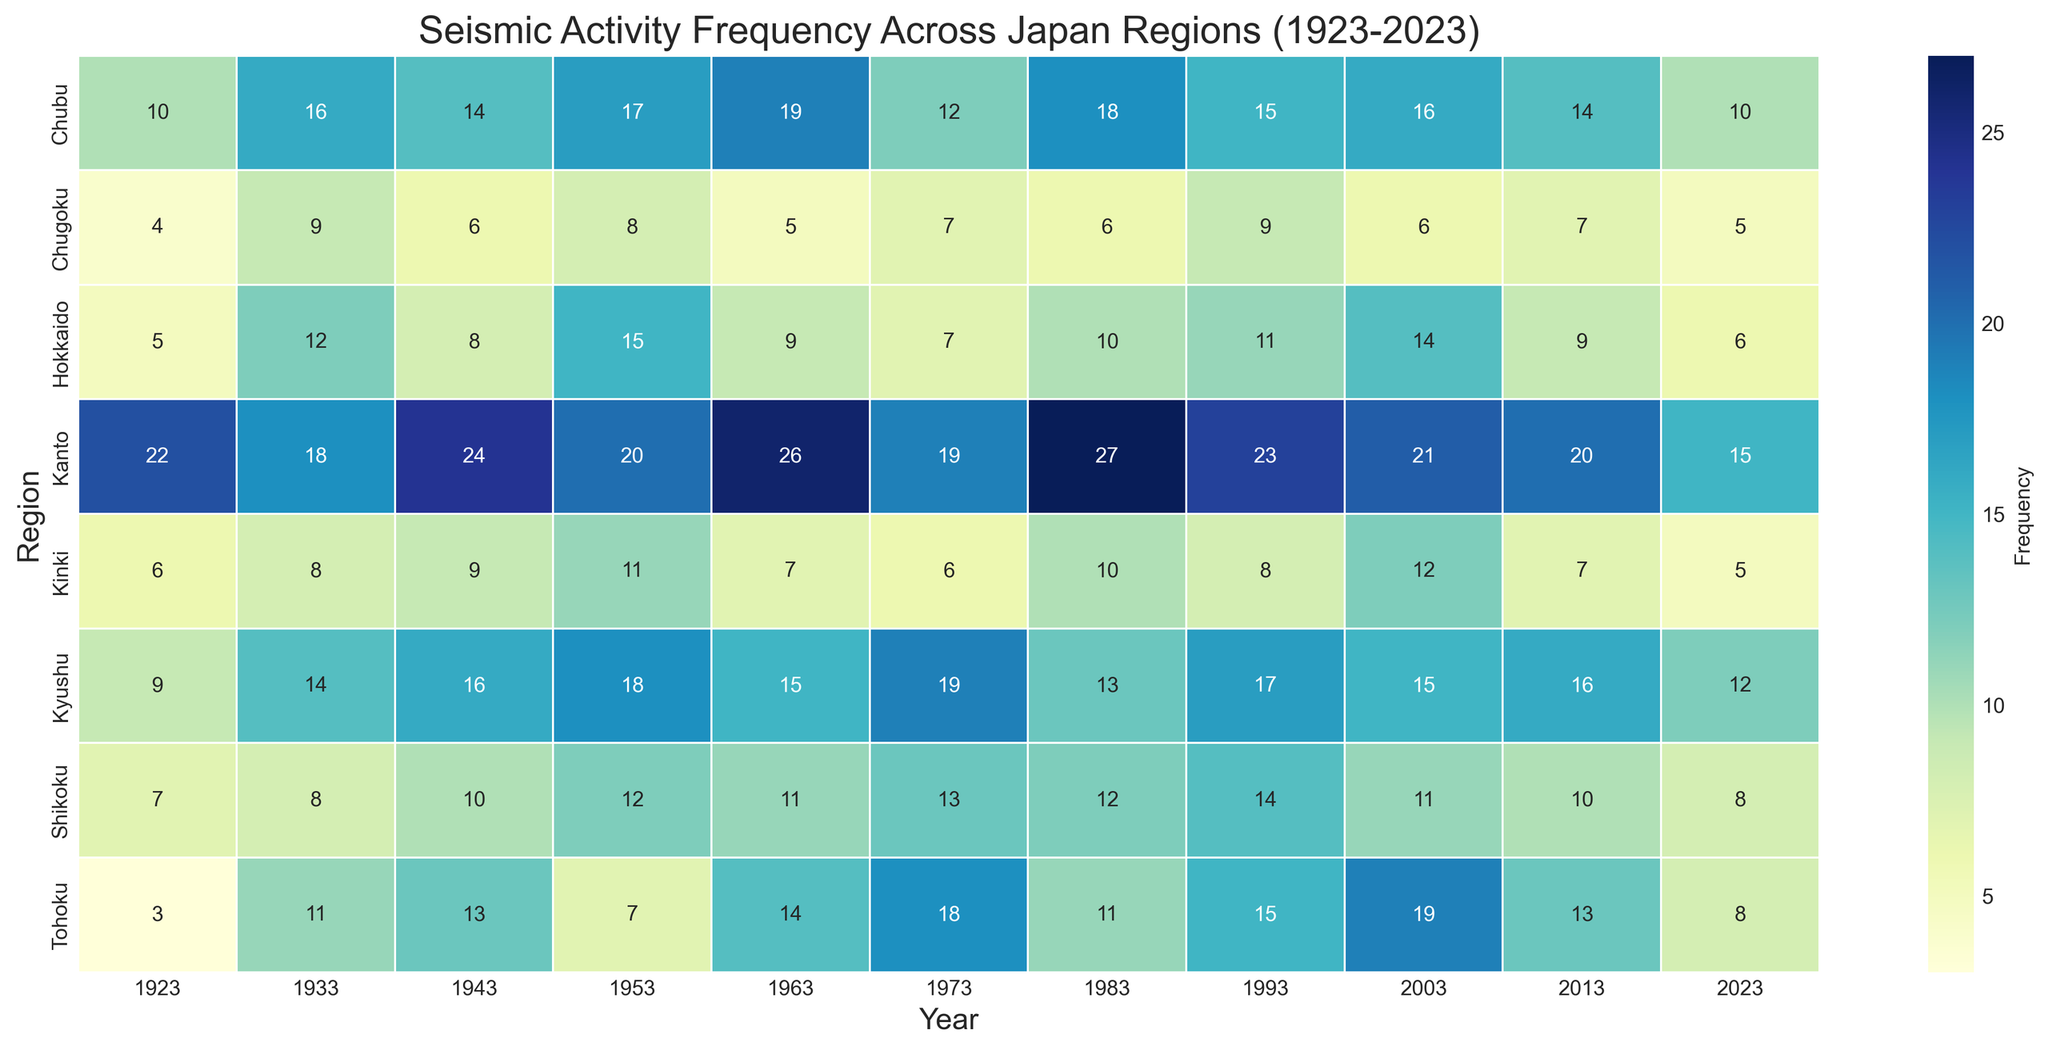Which region has the highest recorded seismic activity frequency and in which year? By examining the heatmap, find the cell with the darkest shade, which signifies the highest frequency. Cross-reference this cell's row (region) and column (year).
Answer: Kanto, 1963 What is the average seismic activity frequency in Kanto across all recorded years? Identify the values for Kanto across all years, then calculate the sum of these values and divide by the number of years (11). Summing values (22 + 18 + 24 + 20 + 26 + 19 + 27 + 23 + 21 + 20 + 15) gives 235. The average is 235 / 11.
Answer: 21.4 Which region experienced the highest increase in seismic activity frequency from 1923 to 1933? Compare the frequency in 1923 to that in 1933 for all regions. Calculate the difference for each region and find the largest difference.
Answer: Hokkaido What was the total seismic activity frequency for Tohoku in the decades of 1973 and 1983 combined? Identify the frequencies for Tohoku in 1973 and 1983, then sum these values. The frequencies are 18 and 11, respectively. Summing these gives (18 + 11).
Answer: 29 Which regions show a decreasing trend in seismic activity frequency from 2003 to 2023? Observe the frequency values for all regions from 2003 to 2023 and check for regions where the frequency constantly decreases. Hokkaido, Kanto, Kinki, and Kyushu show a clear decreasing trend.
Answer: Hokkaido, Kanto, Kinki, Kyushu What is the maximum difference in seismic activity frequency observed in any region between two consecutive decades? Identify the maximum frequency difference between two consecutive decades for all regions. Calculate differences for each pair of decades and determine the largest difference. For instance, Kanto between 1963 and 1973 shows a difference of (26 - 19).
Answer: 9 How does the seismic activity frequency in Chubu in 1943 compare to that in 1953? Examine the values in Chubu for 1943 and 1953 and compare them to determine which one is higher. Chubu has a frequency of 14 in 1943 and 17 in 1953.
Answer: 1953 is higher What color represents the lowest seismic activity frequency on the heatmap, and which regions correspond to this color in 2023? Identify the color (generally the lightest shade) that represents the lowest frequency on the heatmap. In 2023, Hokkaido, Kinki, Chugoku are the regions corresponding to this color.
Answer: Hokkaido, Kinki, Chugoku What trend can be observed in the seismic activity for Kyushu from 1923 to 1973, and how does it change afterward? Find the values for Kyushu from 1923 to 1973 and observe the trend (increasing). Examine values from 1973 to 2023 to observe any changes (fluctuating but generally decreasing). Initially increasing, then fluctuates and decreases
Answer: Increasing until 1973, then fluctuating and decreasing 